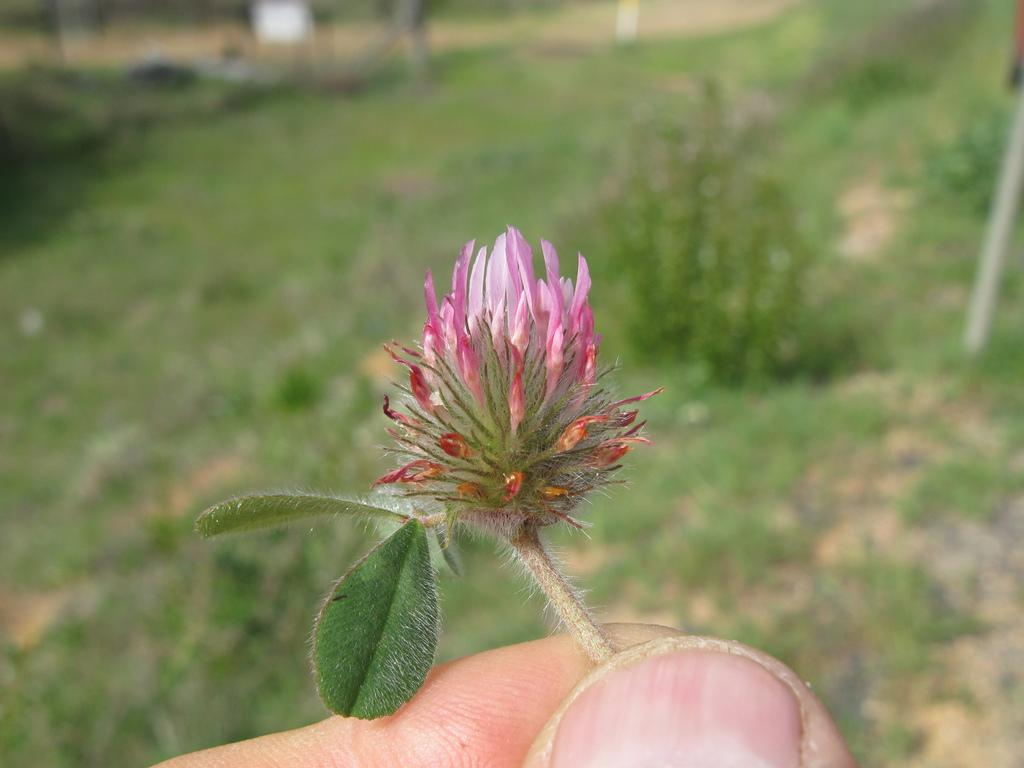What is the person holding in the image? There is a person's hand holding a flower in the image. What can be seen beneath the person's hand? The ground is visible in the image. What type of vegetation is on the ground? There is grass on the ground. What else is present on the ground in the image? There are plants and other objects on the ground. What is the person's opinion about the paper in the image? There is no paper present in the image, so it is not possible to determine the person's opinion about it. 